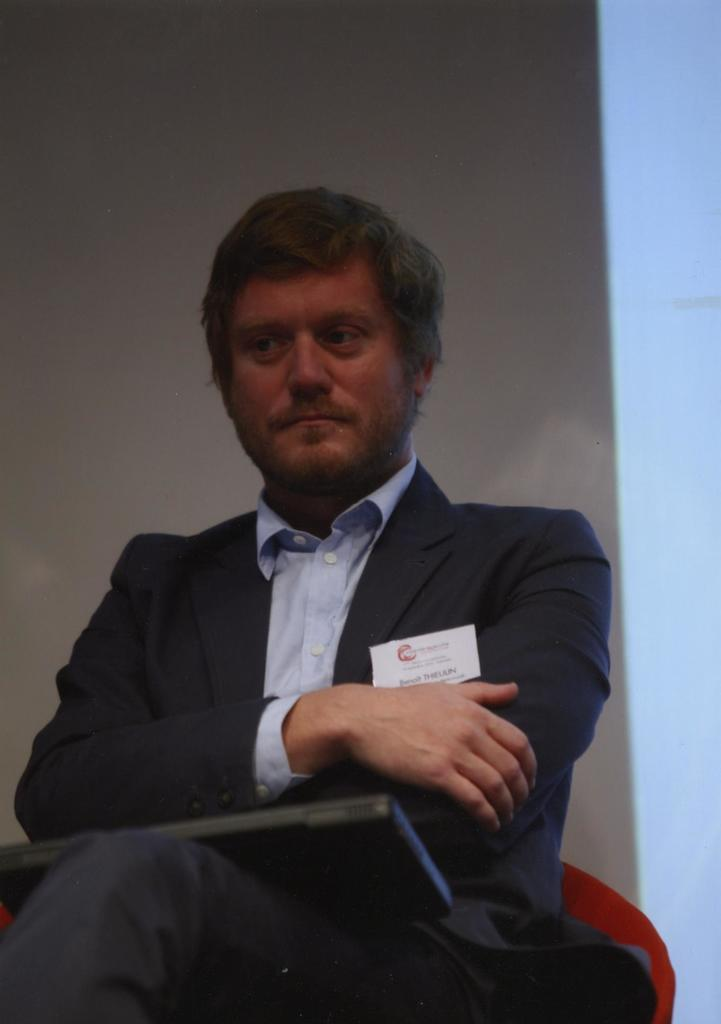What can be observed about the background of the image? The background of the picture is blurry. Who is present in the image? There is a man in the image. What is the man wearing? The man is wearing a blazer. What is the man doing in the image? The man is sitting. What is on the man's lap? There is a black object on the man's lap. How many hands does the donkey have in the image? There is no donkey present in the image, so it is not possible to determine the number of hands it might have. 